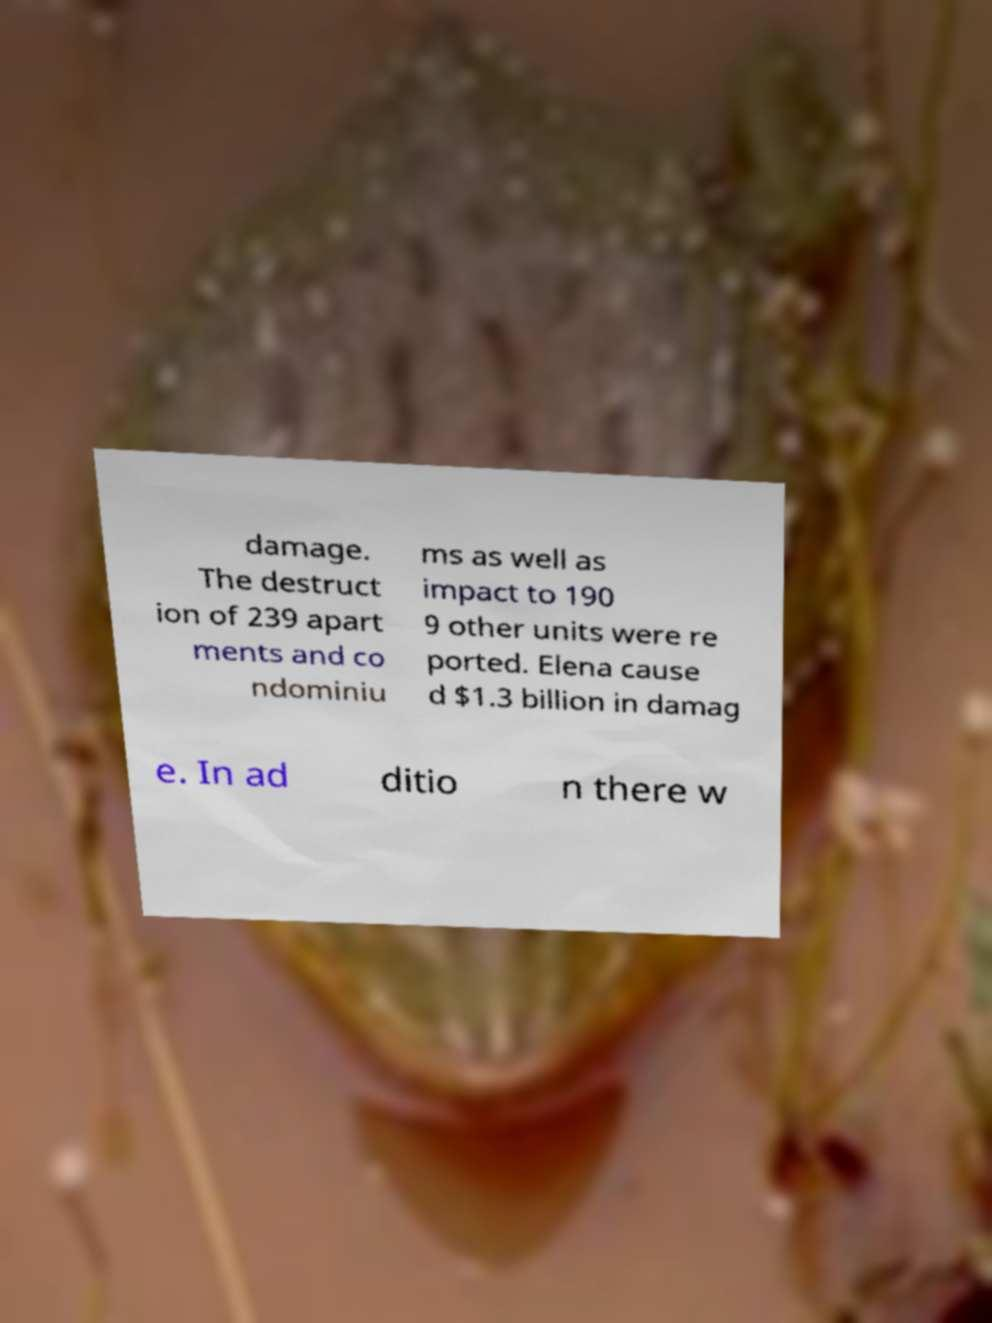Could you extract and type out the text from this image? damage. The destruct ion of 239 apart ments and co ndominiu ms as well as impact to 190 9 other units were re ported. Elena cause d $1.3 billion in damag e. In ad ditio n there w 